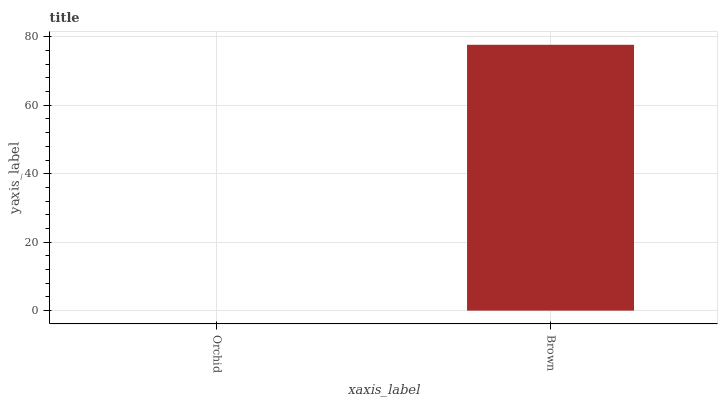Is Orchid the minimum?
Answer yes or no. Yes. Is Brown the maximum?
Answer yes or no. Yes. Is Brown the minimum?
Answer yes or no. No. Is Brown greater than Orchid?
Answer yes or no. Yes. Is Orchid less than Brown?
Answer yes or no. Yes. Is Orchid greater than Brown?
Answer yes or no. No. Is Brown less than Orchid?
Answer yes or no. No. Is Brown the high median?
Answer yes or no. Yes. Is Orchid the low median?
Answer yes or no. Yes. Is Orchid the high median?
Answer yes or no. No. Is Brown the low median?
Answer yes or no. No. 